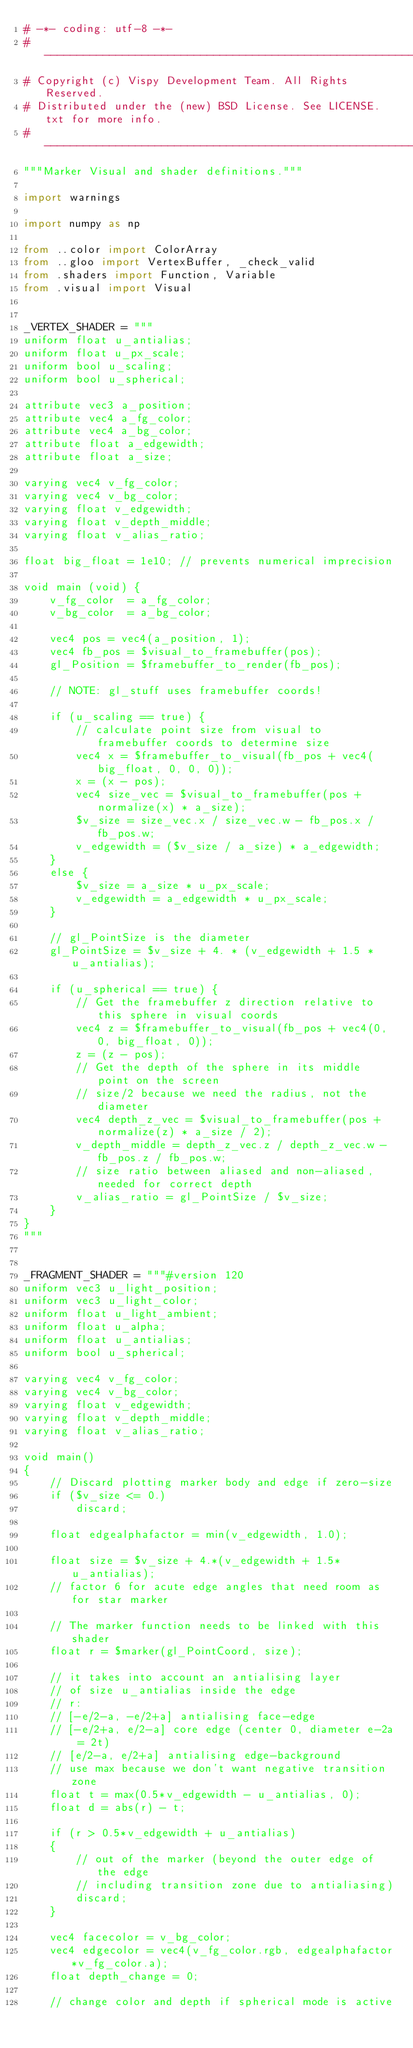Convert code to text. <code><loc_0><loc_0><loc_500><loc_500><_Python_># -*- coding: utf-8 -*-
# -----------------------------------------------------------------------------
# Copyright (c) Vispy Development Team. All Rights Reserved.
# Distributed under the (new) BSD License. See LICENSE.txt for more info.
# -----------------------------------------------------------------------------
"""Marker Visual and shader definitions."""

import warnings

import numpy as np

from ..color import ColorArray
from ..gloo import VertexBuffer, _check_valid
from .shaders import Function, Variable
from .visual import Visual


_VERTEX_SHADER = """
uniform float u_antialias;
uniform float u_px_scale;
uniform bool u_scaling;
uniform bool u_spherical;

attribute vec3 a_position;
attribute vec4 a_fg_color;
attribute vec4 a_bg_color;
attribute float a_edgewidth;
attribute float a_size;

varying vec4 v_fg_color;
varying vec4 v_bg_color;
varying float v_edgewidth;
varying float v_depth_middle;
varying float v_alias_ratio;

float big_float = 1e10; // prevents numerical imprecision

void main (void) {
    v_fg_color  = a_fg_color;
    v_bg_color  = a_bg_color;

    vec4 pos = vec4(a_position, 1);
    vec4 fb_pos = $visual_to_framebuffer(pos);
    gl_Position = $framebuffer_to_render(fb_pos);

    // NOTE: gl_stuff uses framebuffer coords!

    if (u_scaling == true) {
        // calculate point size from visual to framebuffer coords to determine size
        vec4 x = $framebuffer_to_visual(fb_pos + vec4(big_float, 0, 0, 0));
        x = (x - pos);
        vec4 size_vec = $visual_to_framebuffer(pos + normalize(x) * a_size);
        $v_size = size_vec.x / size_vec.w - fb_pos.x / fb_pos.w;
        v_edgewidth = ($v_size / a_size) * a_edgewidth;
    }
    else {
        $v_size = a_size * u_px_scale;
        v_edgewidth = a_edgewidth * u_px_scale;
    }

    // gl_PointSize is the diameter
    gl_PointSize = $v_size + 4. * (v_edgewidth + 1.5 * u_antialias);

    if (u_spherical == true) {
        // Get the framebuffer z direction relative to this sphere in visual coords
        vec4 z = $framebuffer_to_visual(fb_pos + vec4(0, 0, big_float, 0));
        z = (z - pos);
        // Get the depth of the sphere in its middle point on the screen
        // size/2 because we need the radius, not the diameter
        vec4 depth_z_vec = $visual_to_framebuffer(pos + normalize(z) * a_size / 2);
        v_depth_middle = depth_z_vec.z / depth_z_vec.w - fb_pos.z / fb_pos.w;
        // size ratio between aliased and non-aliased, needed for correct depth
        v_alias_ratio = gl_PointSize / $v_size;
    }
}
"""


_FRAGMENT_SHADER = """#version 120
uniform vec3 u_light_position;
uniform vec3 u_light_color;
uniform float u_light_ambient;
uniform float u_alpha;
uniform float u_antialias;
uniform bool u_spherical;

varying vec4 v_fg_color;
varying vec4 v_bg_color;
varying float v_edgewidth;
varying float v_depth_middle;
varying float v_alias_ratio;

void main()
{
    // Discard plotting marker body and edge if zero-size
    if ($v_size <= 0.)
        discard;

    float edgealphafactor = min(v_edgewidth, 1.0);

    float size = $v_size + 4.*(v_edgewidth + 1.5*u_antialias);
    // factor 6 for acute edge angles that need room as for star marker

    // The marker function needs to be linked with this shader
    float r = $marker(gl_PointCoord, size);

    // it takes into account an antialising layer
    // of size u_antialias inside the edge
    // r:
    // [-e/2-a, -e/2+a] antialising face-edge
    // [-e/2+a, e/2-a] core edge (center 0, diameter e-2a = 2t)
    // [e/2-a, e/2+a] antialising edge-background
    // use max because we don't want negative transition zone
    float t = max(0.5*v_edgewidth - u_antialias, 0);
    float d = abs(r) - t;

    if (r > 0.5*v_edgewidth + u_antialias)
    {
        // out of the marker (beyond the outer edge of the edge
        // including transition zone due to antialiasing)
        discard;
    }

    vec4 facecolor = v_bg_color;
    vec4 edgecolor = vec4(v_fg_color.rgb, edgealphafactor*v_fg_color.a);
    float depth_change = 0;

    // change color and depth if spherical mode is active</code> 